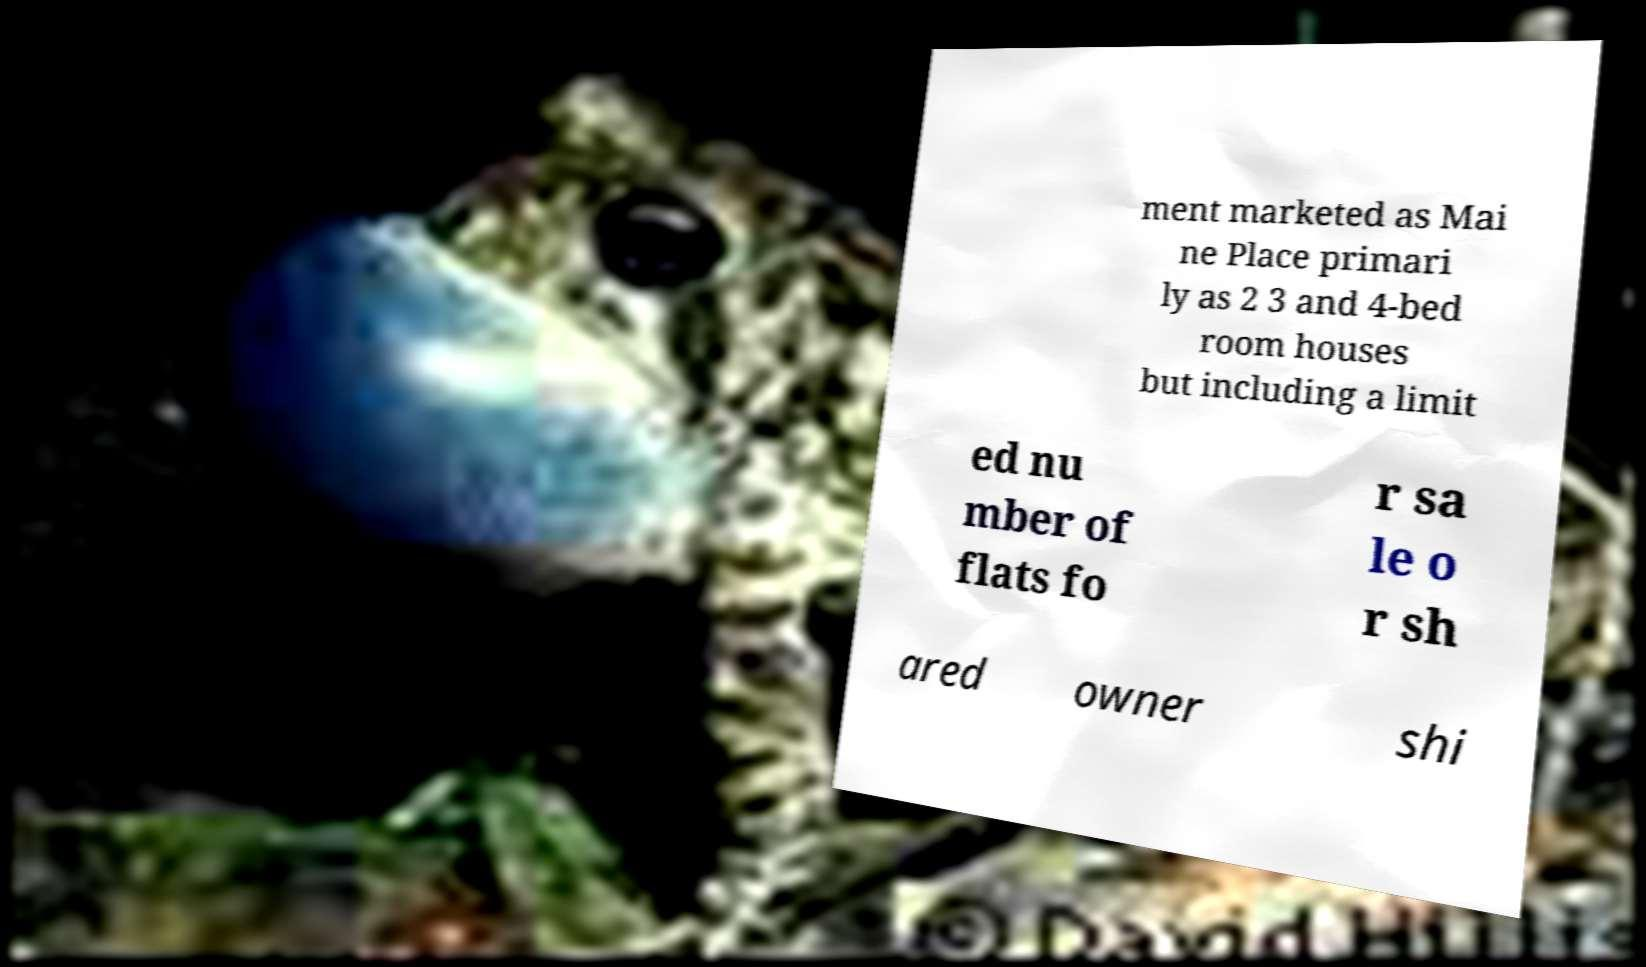Could you assist in decoding the text presented in this image and type it out clearly? ment marketed as Mai ne Place primari ly as 2 3 and 4-bed room houses but including a limit ed nu mber of flats fo r sa le o r sh ared owner shi 